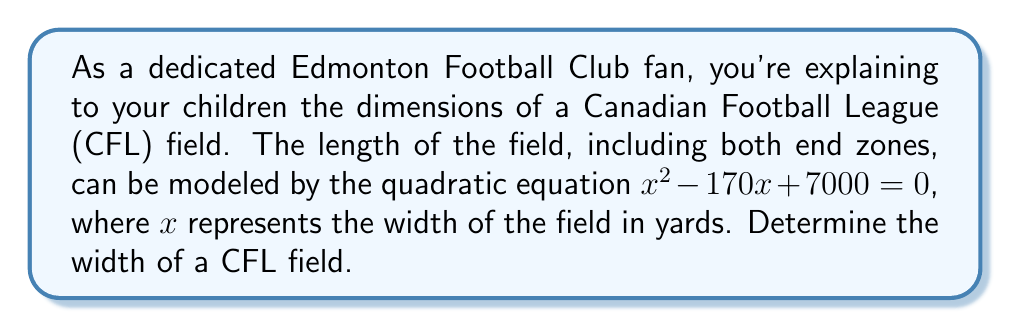What is the answer to this math problem? Let's solve this step-by-step using the quadratic formula:

1) The quadratic formula is: $x = \frac{-b \pm \sqrt{b^2 - 4ac}}{2a}$

2) In our equation $x^2 - 170x + 7000 = 0$, we have:
   $a = 1$
   $b = -170$
   $c = 7000$

3) Substituting these values into the quadratic formula:

   $$x = \frac{-(-170) \pm \sqrt{(-170)^2 - 4(1)(7000)}}{2(1)}$$

4) Simplify:
   $$x = \frac{170 \pm \sqrt{28900 - 28000}}{2}$$
   $$x = \frac{170 \pm \sqrt{900}}{2}$$
   $$x = \frac{170 \pm 30}{2}$$

5) This gives us two solutions:
   $$x = \frac{170 + 30}{2} = \frac{200}{2} = 100$$
   $$x = \frac{170 - 30}{2} = \frac{140}{2} = 70$$

6) The width of a CFL field is 65 yards. The solution closest to this is 70 yards.
Answer: The width of a CFL field is approximately 70 yards. 